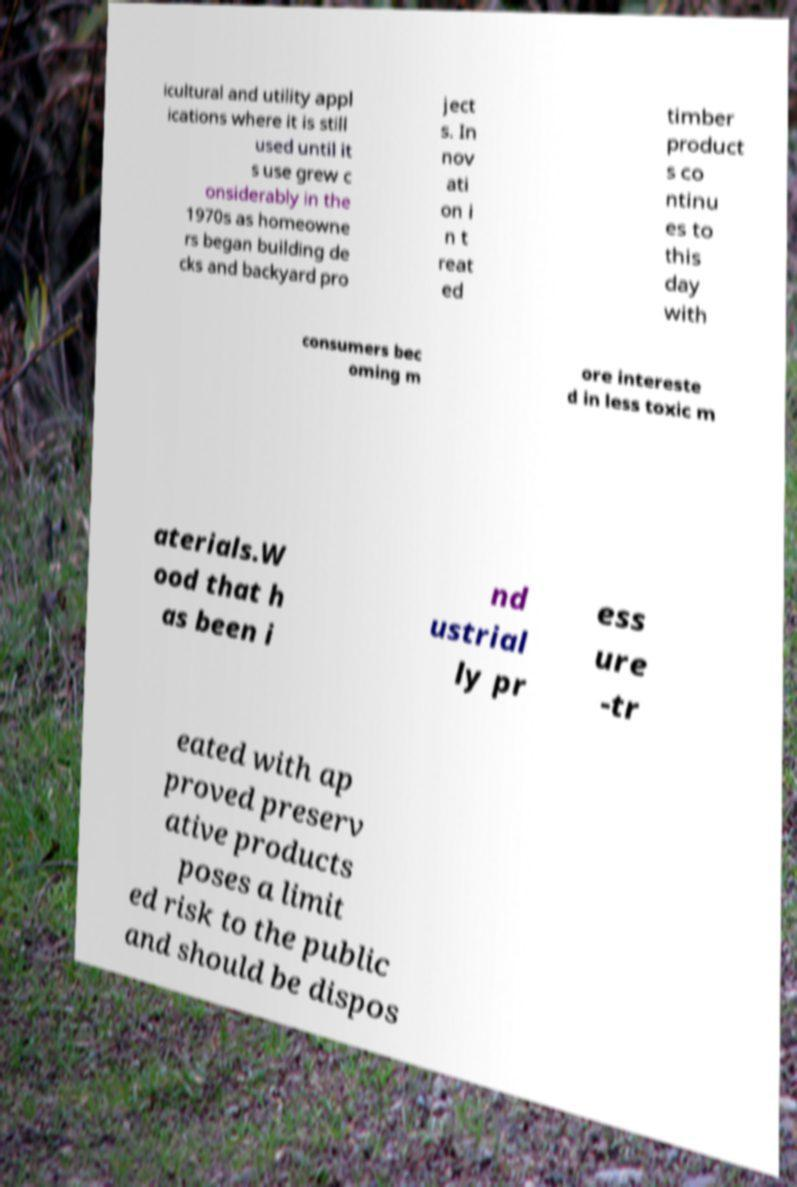I need the written content from this picture converted into text. Can you do that? icultural and utility appl ications where it is still used until it s use grew c onsiderably in the 1970s as homeowne rs began building de cks and backyard pro ject s. In nov ati on i n t reat ed timber product s co ntinu es to this day with consumers bec oming m ore intereste d in less toxic m aterials.W ood that h as been i nd ustrial ly pr ess ure -tr eated with ap proved preserv ative products poses a limit ed risk to the public and should be dispos 